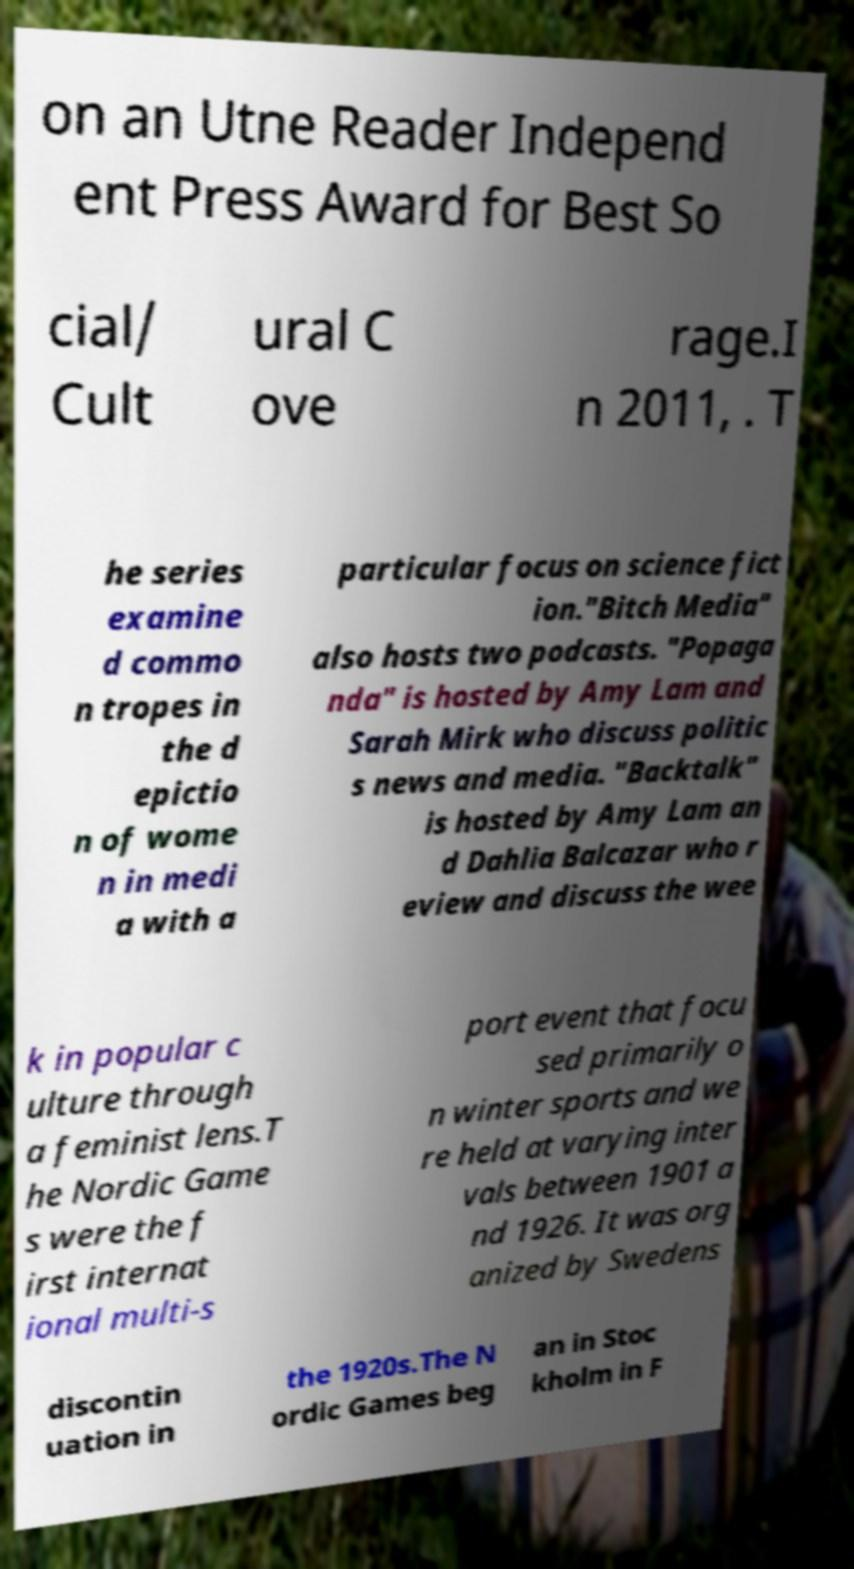Please read and relay the text visible in this image. What does it say? on an Utne Reader Independ ent Press Award for Best So cial/ Cult ural C ove rage.I n 2011, . T he series examine d commo n tropes in the d epictio n of wome n in medi a with a particular focus on science fict ion."Bitch Media" also hosts two podcasts. "Popaga nda" is hosted by Amy Lam and Sarah Mirk who discuss politic s news and media. "Backtalk" is hosted by Amy Lam an d Dahlia Balcazar who r eview and discuss the wee k in popular c ulture through a feminist lens.T he Nordic Game s were the f irst internat ional multi-s port event that focu sed primarily o n winter sports and we re held at varying inter vals between 1901 a nd 1926. It was org anized by Swedens discontin uation in the 1920s.The N ordic Games beg an in Stoc kholm in F 